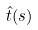<formula> <loc_0><loc_0><loc_500><loc_500>\hat { t } ( s )</formula> 